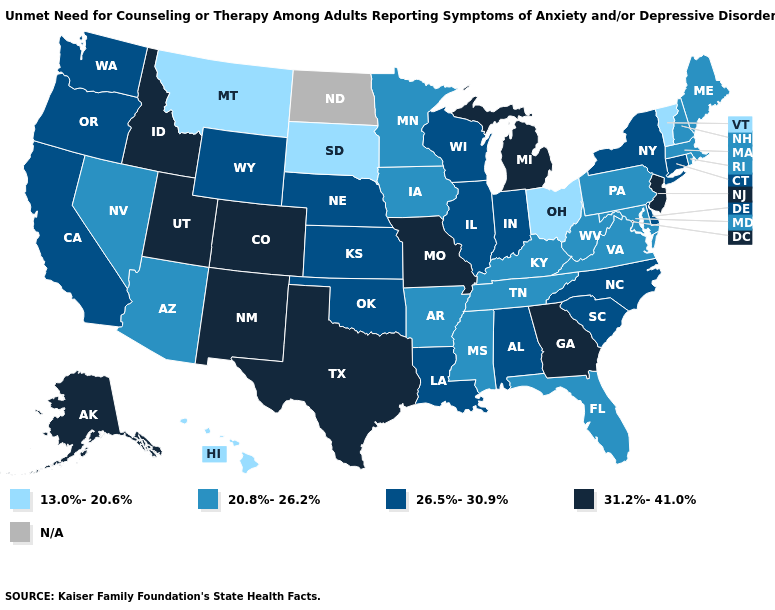Which states have the lowest value in the USA?
Quick response, please. Hawaii, Montana, Ohio, South Dakota, Vermont. What is the value of Ohio?
Quick response, please. 13.0%-20.6%. Name the states that have a value in the range N/A?
Give a very brief answer. North Dakota. What is the lowest value in the South?
Be succinct. 20.8%-26.2%. Among the states that border Virginia , does North Carolina have the highest value?
Answer briefly. Yes. Name the states that have a value in the range 13.0%-20.6%?
Concise answer only. Hawaii, Montana, Ohio, South Dakota, Vermont. Name the states that have a value in the range 20.8%-26.2%?
Keep it brief. Arizona, Arkansas, Florida, Iowa, Kentucky, Maine, Maryland, Massachusetts, Minnesota, Mississippi, Nevada, New Hampshire, Pennsylvania, Rhode Island, Tennessee, Virginia, West Virginia. Does Montana have the lowest value in the USA?
Answer briefly. Yes. Which states have the lowest value in the Northeast?
Short answer required. Vermont. Which states have the highest value in the USA?
Give a very brief answer. Alaska, Colorado, Georgia, Idaho, Michigan, Missouri, New Jersey, New Mexico, Texas, Utah. What is the highest value in the South ?
Answer briefly. 31.2%-41.0%. Name the states that have a value in the range N/A?
Concise answer only. North Dakota. Does the first symbol in the legend represent the smallest category?
Give a very brief answer. Yes. 